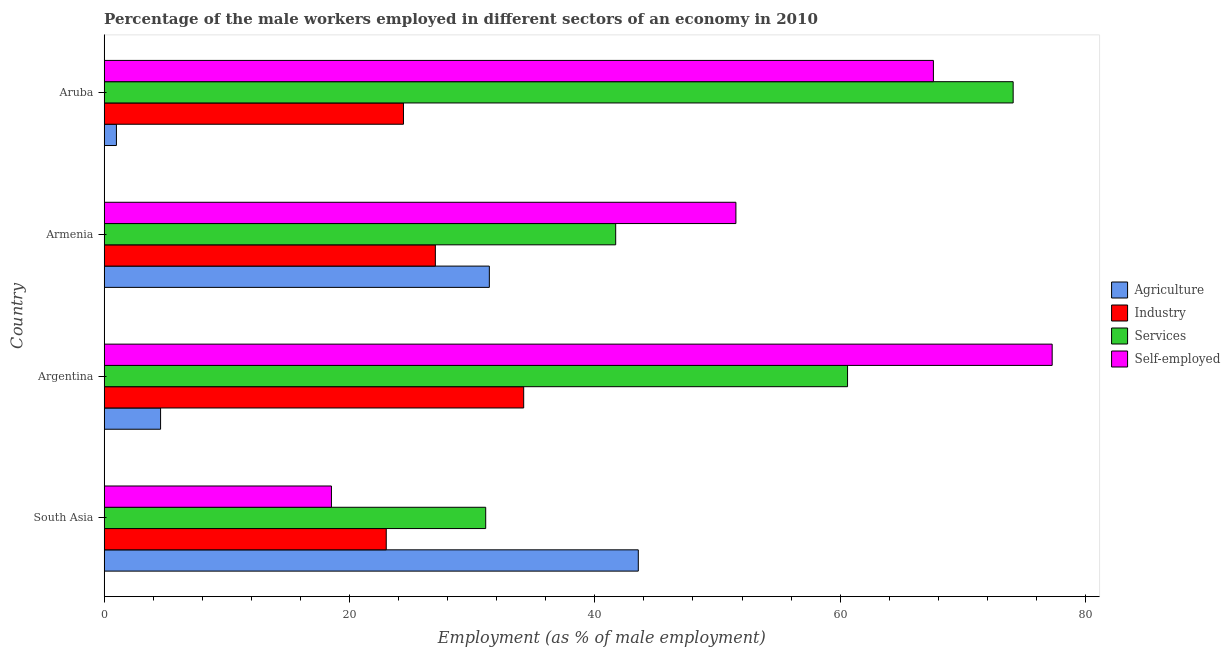Are the number of bars per tick equal to the number of legend labels?
Provide a short and direct response. Yes. Are the number of bars on each tick of the Y-axis equal?
Your response must be concise. Yes. What is the label of the 1st group of bars from the top?
Give a very brief answer. Aruba. What is the percentage of male workers in services in Argentina?
Your answer should be compact. 60.6. Across all countries, what is the maximum percentage of self employed male workers?
Offer a very short reply. 77.28. What is the total percentage of male workers in agriculture in the graph?
Provide a short and direct response. 80.54. What is the difference between the percentage of male workers in agriculture in Argentina and that in Armenia?
Ensure brevity in your answer.  -26.8. What is the difference between the percentage of male workers in services in South Asia and the percentage of male workers in industry in Armenia?
Ensure brevity in your answer.  4.1. What is the average percentage of male workers in industry per country?
Give a very brief answer. 27.15. What is the difference between the percentage of male workers in industry and percentage of self employed male workers in Armenia?
Provide a succinct answer. -24.5. What is the ratio of the percentage of male workers in agriculture in Argentina to that in South Asia?
Ensure brevity in your answer.  0.11. Is the percentage of male workers in industry in Argentina less than that in Aruba?
Your response must be concise. No. What is the difference between the highest and the second highest percentage of male workers in industry?
Provide a succinct answer. 7.2. What is the difference between the highest and the lowest percentage of male workers in industry?
Provide a succinct answer. 11.2. Is it the case that in every country, the sum of the percentage of male workers in agriculture and percentage of male workers in services is greater than the sum of percentage of self employed male workers and percentage of male workers in industry?
Give a very brief answer. Yes. What does the 1st bar from the top in Argentina represents?
Keep it short and to the point. Self-employed. What does the 1st bar from the bottom in South Asia represents?
Provide a succinct answer. Agriculture. Is it the case that in every country, the sum of the percentage of male workers in agriculture and percentage of male workers in industry is greater than the percentage of male workers in services?
Give a very brief answer. No. Are all the bars in the graph horizontal?
Make the answer very short. Yes. How many countries are there in the graph?
Offer a terse response. 4. What is the difference between two consecutive major ticks on the X-axis?
Make the answer very short. 20. Are the values on the major ticks of X-axis written in scientific E-notation?
Keep it short and to the point. No. Does the graph contain any zero values?
Offer a terse response. No. Where does the legend appear in the graph?
Your response must be concise. Center right. How many legend labels are there?
Your answer should be very brief. 4. What is the title of the graph?
Give a very brief answer. Percentage of the male workers employed in different sectors of an economy in 2010. Does "Budget management" appear as one of the legend labels in the graph?
Provide a succinct answer. No. What is the label or title of the X-axis?
Your answer should be compact. Employment (as % of male employment). What is the label or title of the Y-axis?
Your response must be concise. Country. What is the Employment (as % of male employment) in Agriculture in South Asia?
Your answer should be very brief. 43.54. What is the Employment (as % of male employment) in Industry in South Asia?
Your answer should be compact. 23. What is the Employment (as % of male employment) in Services in South Asia?
Offer a very short reply. 31.1. What is the Employment (as % of male employment) in Self-employed in South Asia?
Provide a succinct answer. 18.53. What is the Employment (as % of male employment) in Agriculture in Argentina?
Your response must be concise. 4.6. What is the Employment (as % of male employment) of Industry in Argentina?
Give a very brief answer. 34.2. What is the Employment (as % of male employment) in Services in Argentina?
Your response must be concise. 60.6. What is the Employment (as % of male employment) in Self-employed in Argentina?
Give a very brief answer. 77.28. What is the Employment (as % of male employment) in Agriculture in Armenia?
Offer a terse response. 31.4. What is the Employment (as % of male employment) of Services in Armenia?
Offer a terse response. 41.7. What is the Employment (as % of male employment) in Self-employed in Armenia?
Provide a succinct answer. 51.5. What is the Employment (as % of male employment) of Industry in Aruba?
Provide a succinct answer. 24.4. What is the Employment (as % of male employment) of Services in Aruba?
Ensure brevity in your answer.  74.1. What is the Employment (as % of male employment) in Self-employed in Aruba?
Offer a terse response. 67.6. Across all countries, what is the maximum Employment (as % of male employment) in Agriculture?
Provide a short and direct response. 43.54. Across all countries, what is the maximum Employment (as % of male employment) in Industry?
Your answer should be compact. 34.2. Across all countries, what is the maximum Employment (as % of male employment) of Services?
Your answer should be very brief. 74.1. Across all countries, what is the maximum Employment (as % of male employment) in Self-employed?
Your answer should be very brief. 77.28. Across all countries, what is the minimum Employment (as % of male employment) in Agriculture?
Make the answer very short. 1. Across all countries, what is the minimum Employment (as % of male employment) of Industry?
Provide a succinct answer. 23. Across all countries, what is the minimum Employment (as % of male employment) in Services?
Provide a short and direct response. 31.1. Across all countries, what is the minimum Employment (as % of male employment) of Self-employed?
Your response must be concise. 18.53. What is the total Employment (as % of male employment) in Agriculture in the graph?
Your answer should be compact. 80.54. What is the total Employment (as % of male employment) in Industry in the graph?
Your answer should be compact. 108.6. What is the total Employment (as % of male employment) of Services in the graph?
Ensure brevity in your answer.  207.5. What is the total Employment (as % of male employment) of Self-employed in the graph?
Make the answer very short. 214.91. What is the difference between the Employment (as % of male employment) of Agriculture in South Asia and that in Argentina?
Give a very brief answer. 38.94. What is the difference between the Employment (as % of male employment) in Industry in South Asia and that in Argentina?
Your response must be concise. -11.2. What is the difference between the Employment (as % of male employment) in Services in South Asia and that in Argentina?
Make the answer very short. -29.5. What is the difference between the Employment (as % of male employment) in Self-employed in South Asia and that in Argentina?
Give a very brief answer. -58.75. What is the difference between the Employment (as % of male employment) in Agriculture in South Asia and that in Armenia?
Provide a short and direct response. 12.14. What is the difference between the Employment (as % of male employment) in Industry in South Asia and that in Armenia?
Give a very brief answer. -4. What is the difference between the Employment (as % of male employment) of Services in South Asia and that in Armenia?
Keep it short and to the point. -10.6. What is the difference between the Employment (as % of male employment) of Self-employed in South Asia and that in Armenia?
Your response must be concise. -32.97. What is the difference between the Employment (as % of male employment) of Agriculture in South Asia and that in Aruba?
Your answer should be very brief. 42.54. What is the difference between the Employment (as % of male employment) of Industry in South Asia and that in Aruba?
Ensure brevity in your answer.  -1.4. What is the difference between the Employment (as % of male employment) in Services in South Asia and that in Aruba?
Offer a terse response. -43. What is the difference between the Employment (as % of male employment) in Self-employed in South Asia and that in Aruba?
Offer a terse response. -49.07. What is the difference between the Employment (as % of male employment) of Agriculture in Argentina and that in Armenia?
Offer a terse response. -26.8. What is the difference between the Employment (as % of male employment) in Self-employed in Argentina and that in Armenia?
Keep it short and to the point. 25.78. What is the difference between the Employment (as % of male employment) of Industry in Argentina and that in Aruba?
Give a very brief answer. 9.8. What is the difference between the Employment (as % of male employment) in Self-employed in Argentina and that in Aruba?
Provide a short and direct response. 9.68. What is the difference between the Employment (as % of male employment) of Agriculture in Armenia and that in Aruba?
Offer a terse response. 30.4. What is the difference between the Employment (as % of male employment) in Services in Armenia and that in Aruba?
Make the answer very short. -32.4. What is the difference between the Employment (as % of male employment) of Self-employed in Armenia and that in Aruba?
Your answer should be compact. -16.1. What is the difference between the Employment (as % of male employment) of Agriculture in South Asia and the Employment (as % of male employment) of Industry in Argentina?
Make the answer very short. 9.34. What is the difference between the Employment (as % of male employment) in Agriculture in South Asia and the Employment (as % of male employment) in Services in Argentina?
Provide a succinct answer. -17.06. What is the difference between the Employment (as % of male employment) of Agriculture in South Asia and the Employment (as % of male employment) of Self-employed in Argentina?
Provide a succinct answer. -33.74. What is the difference between the Employment (as % of male employment) in Industry in South Asia and the Employment (as % of male employment) in Services in Argentina?
Make the answer very short. -37.6. What is the difference between the Employment (as % of male employment) in Industry in South Asia and the Employment (as % of male employment) in Self-employed in Argentina?
Provide a succinct answer. -54.28. What is the difference between the Employment (as % of male employment) of Services in South Asia and the Employment (as % of male employment) of Self-employed in Argentina?
Offer a very short reply. -46.18. What is the difference between the Employment (as % of male employment) of Agriculture in South Asia and the Employment (as % of male employment) of Industry in Armenia?
Your response must be concise. 16.54. What is the difference between the Employment (as % of male employment) of Agriculture in South Asia and the Employment (as % of male employment) of Services in Armenia?
Your response must be concise. 1.84. What is the difference between the Employment (as % of male employment) of Agriculture in South Asia and the Employment (as % of male employment) of Self-employed in Armenia?
Keep it short and to the point. -7.96. What is the difference between the Employment (as % of male employment) in Industry in South Asia and the Employment (as % of male employment) in Services in Armenia?
Provide a short and direct response. -18.7. What is the difference between the Employment (as % of male employment) of Industry in South Asia and the Employment (as % of male employment) of Self-employed in Armenia?
Your answer should be compact. -28.5. What is the difference between the Employment (as % of male employment) in Services in South Asia and the Employment (as % of male employment) in Self-employed in Armenia?
Provide a succinct answer. -20.4. What is the difference between the Employment (as % of male employment) of Agriculture in South Asia and the Employment (as % of male employment) of Industry in Aruba?
Provide a short and direct response. 19.14. What is the difference between the Employment (as % of male employment) in Agriculture in South Asia and the Employment (as % of male employment) in Services in Aruba?
Offer a very short reply. -30.56. What is the difference between the Employment (as % of male employment) in Agriculture in South Asia and the Employment (as % of male employment) in Self-employed in Aruba?
Offer a very short reply. -24.06. What is the difference between the Employment (as % of male employment) in Industry in South Asia and the Employment (as % of male employment) in Services in Aruba?
Give a very brief answer. -51.1. What is the difference between the Employment (as % of male employment) in Industry in South Asia and the Employment (as % of male employment) in Self-employed in Aruba?
Your answer should be compact. -44.6. What is the difference between the Employment (as % of male employment) of Services in South Asia and the Employment (as % of male employment) of Self-employed in Aruba?
Your response must be concise. -36.5. What is the difference between the Employment (as % of male employment) in Agriculture in Argentina and the Employment (as % of male employment) in Industry in Armenia?
Provide a short and direct response. -22.4. What is the difference between the Employment (as % of male employment) of Agriculture in Argentina and the Employment (as % of male employment) of Services in Armenia?
Make the answer very short. -37.1. What is the difference between the Employment (as % of male employment) in Agriculture in Argentina and the Employment (as % of male employment) in Self-employed in Armenia?
Ensure brevity in your answer.  -46.9. What is the difference between the Employment (as % of male employment) of Industry in Argentina and the Employment (as % of male employment) of Services in Armenia?
Keep it short and to the point. -7.5. What is the difference between the Employment (as % of male employment) of Industry in Argentina and the Employment (as % of male employment) of Self-employed in Armenia?
Keep it short and to the point. -17.3. What is the difference between the Employment (as % of male employment) of Services in Argentina and the Employment (as % of male employment) of Self-employed in Armenia?
Your answer should be very brief. 9.1. What is the difference between the Employment (as % of male employment) in Agriculture in Argentina and the Employment (as % of male employment) in Industry in Aruba?
Provide a short and direct response. -19.8. What is the difference between the Employment (as % of male employment) of Agriculture in Argentina and the Employment (as % of male employment) of Services in Aruba?
Provide a short and direct response. -69.5. What is the difference between the Employment (as % of male employment) of Agriculture in Argentina and the Employment (as % of male employment) of Self-employed in Aruba?
Provide a short and direct response. -63. What is the difference between the Employment (as % of male employment) in Industry in Argentina and the Employment (as % of male employment) in Services in Aruba?
Offer a very short reply. -39.9. What is the difference between the Employment (as % of male employment) of Industry in Argentina and the Employment (as % of male employment) of Self-employed in Aruba?
Your response must be concise. -33.4. What is the difference between the Employment (as % of male employment) of Agriculture in Armenia and the Employment (as % of male employment) of Industry in Aruba?
Your response must be concise. 7. What is the difference between the Employment (as % of male employment) of Agriculture in Armenia and the Employment (as % of male employment) of Services in Aruba?
Make the answer very short. -42.7. What is the difference between the Employment (as % of male employment) of Agriculture in Armenia and the Employment (as % of male employment) of Self-employed in Aruba?
Your answer should be very brief. -36.2. What is the difference between the Employment (as % of male employment) of Industry in Armenia and the Employment (as % of male employment) of Services in Aruba?
Your answer should be compact. -47.1. What is the difference between the Employment (as % of male employment) of Industry in Armenia and the Employment (as % of male employment) of Self-employed in Aruba?
Keep it short and to the point. -40.6. What is the difference between the Employment (as % of male employment) of Services in Armenia and the Employment (as % of male employment) of Self-employed in Aruba?
Your answer should be compact. -25.9. What is the average Employment (as % of male employment) of Agriculture per country?
Your answer should be very brief. 20.14. What is the average Employment (as % of male employment) of Industry per country?
Your answer should be compact. 27.15. What is the average Employment (as % of male employment) in Services per country?
Ensure brevity in your answer.  51.88. What is the average Employment (as % of male employment) of Self-employed per country?
Give a very brief answer. 53.73. What is the difference between the Employment (as % of male employment) of Agriculture and Employment (as % of male employment) of Industry in South Asia?
Your answer should be very brief. 20.55. What is the difference between the Employment (as % of male employment) of Agriculture and Employment (as % of male employment) of Services in South Asia?
Keep it short and to the point. 12.44. What is the difference between the Employment (as % of male employment) of Agriculture and Employment (as % of male employment) of Self-employed in South Asia?
Make the answer very short. 25.01. What is the difference between the Employment (as % of male employment) of Industry and Employment (as % of male employment) of Services in South Asia?
Your answer should be compact. -8.11. What is the difference between the Employment (as % of male employment) in Industry and Employment (as % of male employment) in Self-employed in South Asia?
Keep it short and to the point. 4.47. What is the difference between the Employment (as % of male employment) of Services and Employment (as % of male employment) of Self-employed in South Asia?
Your answer should be very brief. 12.57. What is the difference between the Employment (as % of male employment) in Agriculture and Employment (as % of male employment) in Industry in Argentina?
Your response must be concise. -29.6. What is the difference between the Employment (as % of male employment) of Agriculture and Employment (as % of male employment) of Services in Argentina?
Make the answer very short. -56. What is the difference between the Employment (as % of male employment) in Agriculture and Employment (as % of male employment) in Self-employed in Argentina?
Provide a succinct answer. -72.68. What is the difference between the Employment (as % of male employment) of Industry and Employment (as % of male employment) of Services in Argentina?
Provide a succinct answer. -26.4. What is the difference between the Employment (as % of male employment) in Industry and Employment (as % of male employment) in Self-employed in Argentina?
Keep it short and to the point. -43.08. What is the difference between the Employment (as % of male employment) in Services and Employment (as % of male employment) in Self-employed in Argentina?
Ensure brevity in your answer.  -16.68. What is the difference between the Employment (as % of male employment) of Agriculture and Employment (as % of male employment) of Services in Armenia?
Provide a succinct answer. -10.3. What is the difference between the Employment (as % of male employment) in Agriculture and Employment (as % of male employment) in Self-employed in Armenia?
Your answer should be very brief. -20.1. What is the difference between the Employment (as % of male employment) of Industry and Employment (as % of male employment) of Services in Armenia?
Offer a very short reply. -14.7. What is the difference between the Employment (as % of male employment) of Industry and Employment (as % of male employment) of Self-employed in Armenia?
Your response must be concise. -24.5. What is the difference between the Employment (as % of male employment) of Services and Employment (as % of male employment) of Self-employed in Armenia?
Provide a short and direct response. -9.8. What is the difference between the Employment (as % of male employment) of Agriculture and Employment (as % of male employment) of Industry in Aruba?
Your response must be concise. -23.4. What is the difference between the Employment (as % of male employment) in Agriculture and Employment (as % of male employment) in Services in Aruba?
Your response must be concise. -73.1. What is the difference between the Employment (as % of male employment) in Agriculture and Employment (as % of male employment) in Self-employed in Aruba?
Your answer should be compact. -66.6. What is the difference between the Employment (as % of male employment) in Industry and Employment (as % of male employment) in Services in Aruba?
Ensure brevity in your answer.  -49.7. What is the difference between the Employment (as % of male employment) of Industry and Employment (as % of male employment) of Self-employed in Aruba?
Provide a succinct answer. -43.2. What is the ratio of the Employment (as % of male employment) of Agriculture in South Asia to that in Argentina?
Provide a succinct answer. 9.47. What is the ratio of the Employment (as % of male employment) of Industry in South Asia to that in Argentina?
Make the answer very short. 0.67. What is the ratio of the Employment (as % of male employment) of Services in South Asia to that in Argentina?
Ensure brevity in your answer.  0.51. What is the ratio of the Employment (as % of male employment) in Self-employed in South Asia to that in Argentina?
Provide a succinct answer. 0.24. What is the ratio of the Employment (as % of male employment) in Agriculture in South Asia to that in Armenia?
Your response must be concise. 1.39. What is the ratio of the Employment (as % of male employment) in Industry in South Asia to that in Armenia?
Ensure brevity in your answer.  0.85. What is the ratio of the Employment (as % of male employment) in Services in South Asia to that in Armenia?
Ensure brevity in your answer.  0.75. What is the ratio of the Employment (as % of male employment) in Self-employed in South Asia to that in Armenia?
Provide a short and direct response. 0.36. What is the ratio of the Employment (as % of male employment) of Agriculture in South Asia to that in Aruba?
Ensure brevity in your answer.  43.54. What is the ratio of the Employment (as % of male employment) of Industry in South Asia to that in Aruba?
Offer a terse response. 0.94. What is the ratio of the Employment (as % of male employment) of Services in South Asia to that in Aruba?
Provide a succinct answer. 0.42. What is the ratio of the Employment (as % of male employment) in Self-employed in South Asia to that in Aruba?
Give a very brief answer. 0.27. What is the ratio of the Employment (as % of male employment) of Agriculture in Argentina to that in Armenia?
Offer a terse response. 0.15. What is the ratio of the Employment (as % of male employment) of Industry in Argentina to that in Armenia?
Your response must be concise. 1.27. What is the ratio of the Employment (as % of male employment) in Services in Argentina to that in Armenia?
Your answer should be very brief. 1.45. What is the ratio of the Employment (as % of male employment) in Self-employed in Argentina to that in Armenia?
Make the answer very short. 1.5. What is the ratio of the Employment (as % of male employment) of Industry in Argentina to that in Aruba?
Provide a succinct answer. 1.4. What is the ratio of the Employment (as % of male employment) in Services in Argentina to that in Aruba?
Your response must be concise. 0.82. What is the ratio of the Employment (as % of male employment) in Self-employed in Argentina to that in Aruba?
Make the answer very short. 1.14. What is the ratio of the Employment (as % of male employment) in Agriculture in Armenia to that in Aruba?
Provide a succinct answer. 31.4. What is the ratio of the Employment (as % of male employment) of Industry in Armenia to that in Aruba?
Give a very brief answer. 1.11. What is the ratio of the Employment (as % of male employment) in Services in Armenia to that in Aruba?
Ensure brevity in your answer.  0.56. What is the ratio of the Employment (as % of male employment) in Self-employed in Armenia to that in Aruba?
Provide a succinct answer. 0.76. What is the difference between the highest and the second highest Employment (as % of male employment) of Agriculture?
Keep it short and to the point. 12.14. What is the difference between the highest and the second highest Employment (as % of male employment) in Industry?
Ensure brevity in your answer.  7.2. What is the difference between the highest and the second highest Employment (as % of male employment) in Services?
Provide a short and direct response. 13.5. What is the difference between the highest and the second highest Employment (as % of male employment) of Self-employed?
Keep it short and to the point. 9.68. What is the difference between the highest and the lowest Employment (as % of male employment) in Agriculture?
Provide a short and direct response. 42.54. What is the difference between the highest and the lowest Employment (as % of male employment) in Industry?
Your response must be concise. 11.2. What is the difference between the highest and the lowest Employment (as % of male employment) of Services?
Offer a very short reply. 43. What is the difference between the highest and the lowest Employment (as % of male employment) of Self-employed?
Your answer should be compact. 58.75. 